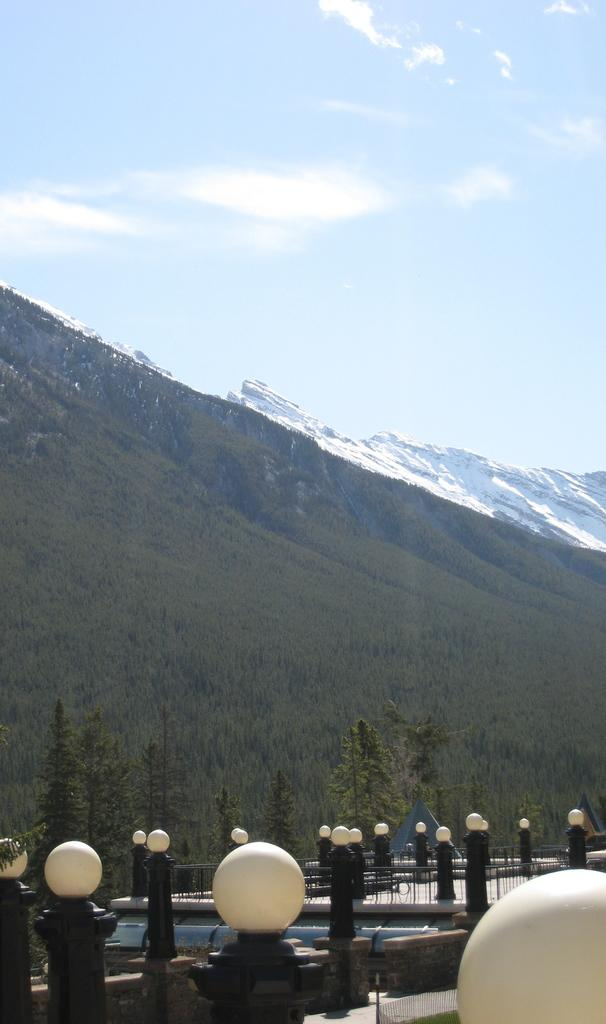What animals are present in the image? There are moles in the image. What can be seen illuminating the scene in the image? There are lights in the image. What type of natural scenery is visible in the background of the image? There are trees, mountains, clouds, and the sky visible in the background of the image. What color is the body of the mole in the image? The provided facts do not mention the color of the moles, so we cannot determine their color from the image. 